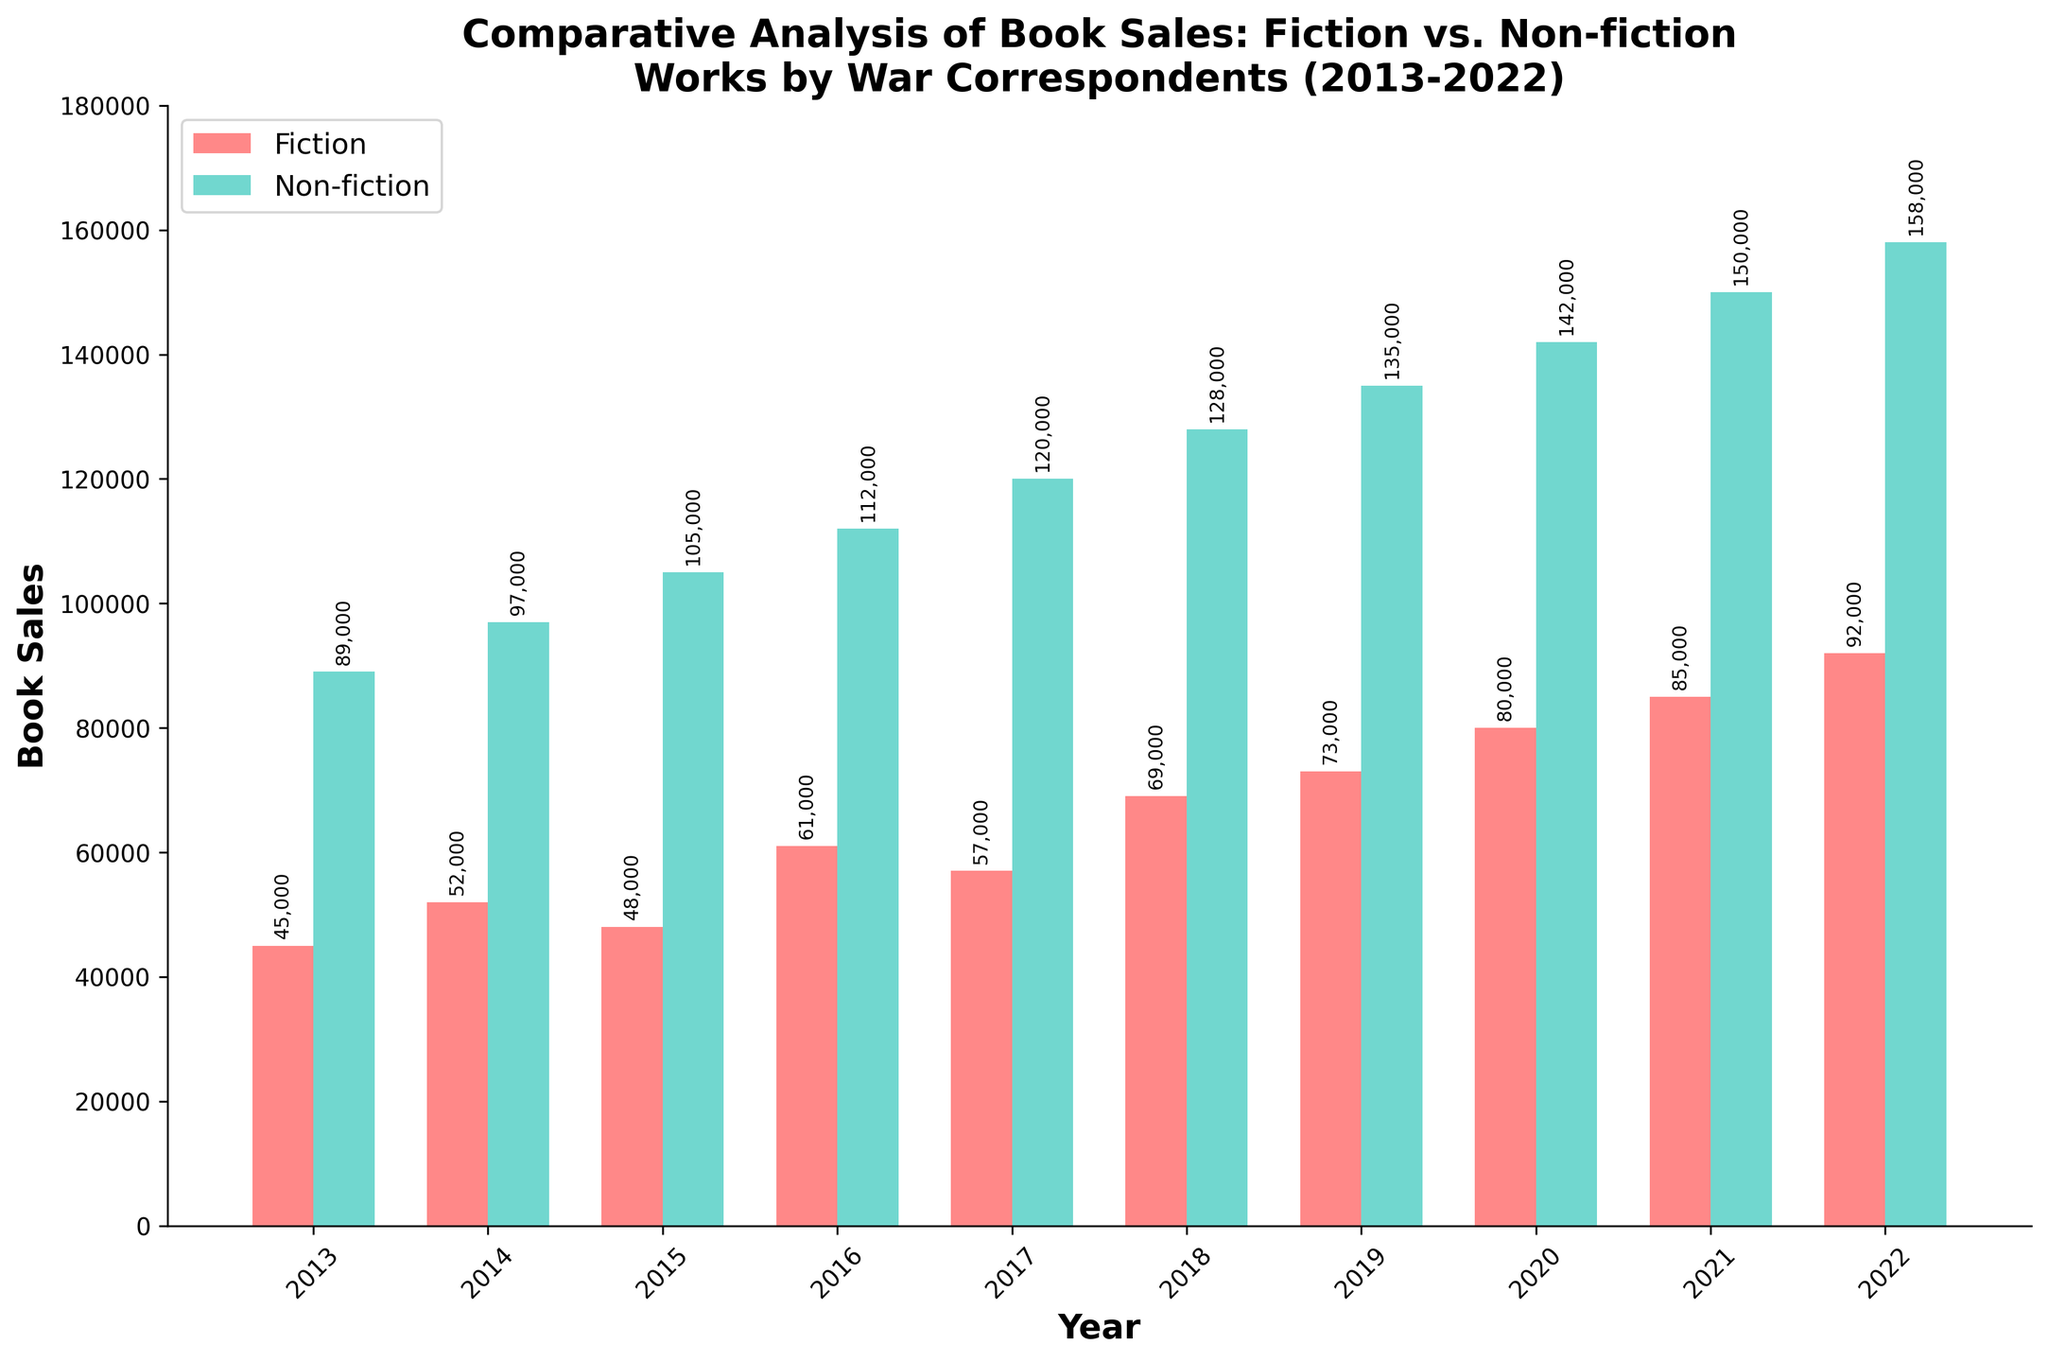What is the difference in book sales between Fiction and Non-fiction in 2022? To find the difference, subtract the sales of Fiction (92,000) from the sales of Non-fiction (158,000). The difference is 158,000 - 92,000.
Answer: 66,000 Which year had the highest book sales for Fiction? Check the heights of the Fiction bars and identify the tallest one. The tallest bar in the Fiction category corresponds to the year 2022 with 92,000 sales.
Answer: 2022 In which year did Non-fiction sales surpass 100,000? Look at the Non-fiction bars and find the first year where the bar height exceeds 100,000. Non-fiction sales surpassed 100,000 in 2015 (105,000).
Answer: 2015 What's the total combined sales of Fiction and Non-fiction in 2020? Add the Fiction sales (80,000) and Non-fiction sales (142,000) for the year 2020. The total is 80,000 + 142,000.
Answer: 222,000 By how much did Fiction book sales increase from 2018 to 2022? Subtract the Fiction sales in 2018 (69,000) from the sales in 2022 (92,000). The increase is 92,000 - 69,000.
Answer: 23,000 Which category, Fiction or Non-fiction, showed a more significant growth from 2013 to 2022? Calculate the growth for both categories by subtracting 2013 sales from 2022 sales. Fiction growth is 92,000 - 45,000 = 47,000. Non-fiction growth is 158,000 - 89,000 = 69,000. Compare these values. Non-fiction showed more significant growth.
Answer: Non-fiction What is the average annual sales of Fiction books over the decade? Sum the annual Fiction sales and divide by the number of years. (45,000 + 52,000 + 48,000 + 61,000 + 57,000 + 69,000 + 73,000 + 80,000 + 85,000 + 92,000) / 10 = 66,200.
Answer: 66,200 How did the sales trend of Non-fiction books change throughout the decade? Observe the Non-fiction bars from 2013 to 2022. The trend shows a steady increase every year, starting from 89,000 in 2013 and reaching 158,000 in 2022.
Answer: Steady increase In which year did Fiction sales experience the highest yearly growth, and what was the value? Calculate the yearly growth for Fiction sales for each year and find the highest. Growths are: 2014: 52,000-45,000=7,000, 2015: 48,000-52,000=-4,000, 2016: 61,000-48,000=13,000, 2017: 57,000-61,000=-4,000, 2018: 69,000-57,000=12,000, 2019: 73,000-69,000=4,000, 2020: 80,000-73,000=7,000, 2021: 85,000-80,000=5,000, 2022: 92,000-85,000=7,000. The highest yearly growth was in 2016 with 13,000.
Answer: 2016, 13,000 How do the colors differentiate the Fiction and Non-fiction categories in the bar chart? The Fiction books are represented by red bars, while Non-fiction books are shown with green bars. This visual distinction helps in easily comparing the two categories.
Answer: Red for Fiction, Green for Non-fiction 